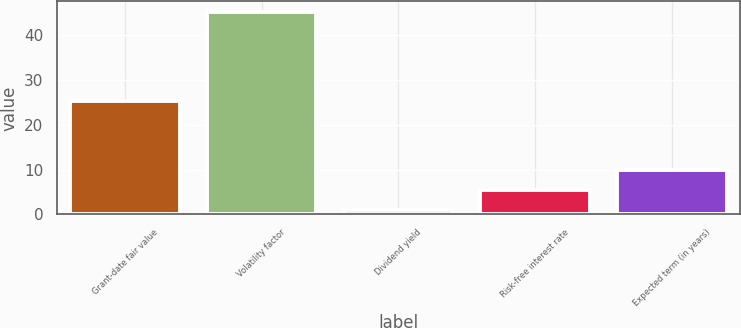<chart> <loc_0><loc_0><loc_500><loc_500><bar_chart><fcel>Grant-date fair value<fcel>Volatility factor<fcel>Dividend yield<fcel>Risk-free interest rate<fcel>Expected term (in years)<nl><fcel>25.41<fcel>45.3<fcel>1<fcel>5.43<fcel>9.86<nl></chart> 